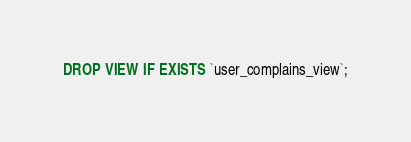Convert code to text. <code><loc_0><loc_0><loc_500><loc_500><_SQL_>DROP VIEW IF EXISTS `user_complains_view`;</code> 